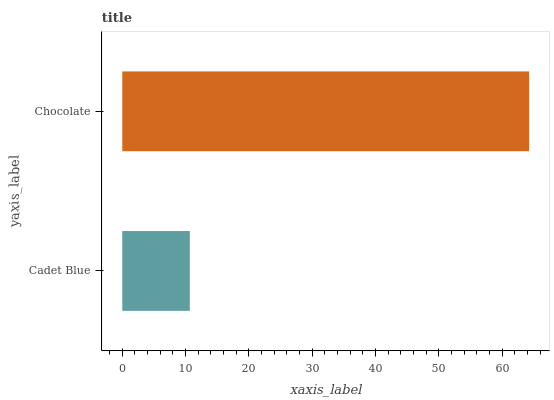Is Cadet Blue the minimum?
Answer yes or no. Yes. Is Chocolate the maximum?
Answer yes or no. Yes. Is Chocolate the minimum?
Answer yes or no. No. Is Chocolate greater than Cadet Blue?
Answer yes or no. Yes. Is Cadet Blue less than Chocolate?
Answer yes or no. Yes. Is Cadet Blue greater than Chocolate?
Answer yes or no. No. Is Chocolate less than Cadet Blue?
Answer yes or no. No. Is Chocolate the high median?
Answer yes or no. Yes. Is Cadet Blue the low median?
Answer yes or no. Yes. Is Cadet Blue the high median?
Answer yes or no. No. Is Chocolate the low median?
Answer yes or no. No. 